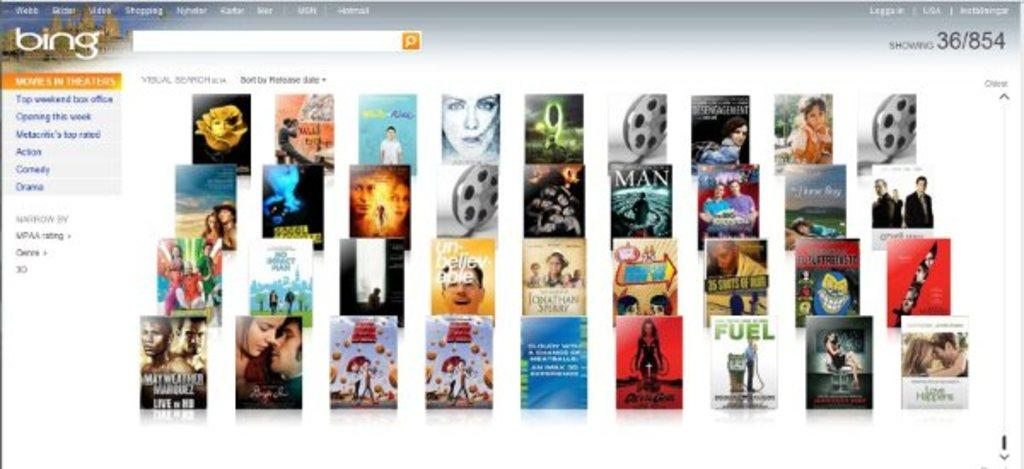What is the main subject of the image? The main subject of the image is a screenshot. What can be seen within the screenshot? The screenshot contains multiple pictures. What feature is present in the screenshot for searching or browsing? There is a search bar visible in the screenshot. What information is entered in the search bar? There is text written in the search bar. Can you see a kitty playing with a horse in the sink in the image? No, there is no kitty, horse, or sink present in the image. The image contains a screenshot with multiple pictures and a search bar. 